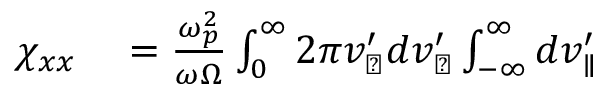Convert formula to latex. <formula><loc_0><loc_0><loc_500><loc_500>\begin{array} { r l } { \chi _ { x x } } & = \frac { \omega _ { p } ^ { 2 } } { \omega \Omega } \int _ { 0 } ^ { \infty } 2 \pi v _ { \perp } ^ { \prime } d v _ { \perp } ^ { \prime } \int _ { - \infty } ^ { \infty } d v _ { \| } ^ { \prime } } \end{array}</formula> 